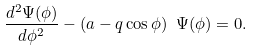<formula> <loc_0><loc_0><loc_500><loc_500>\frac { d ^ { 2 } \Psi ( \phi ) } { d \phi ^ { 2 } } - ( a - q \cos \phi ) \ \Psi ( \phi ) = 0 .</formula> 